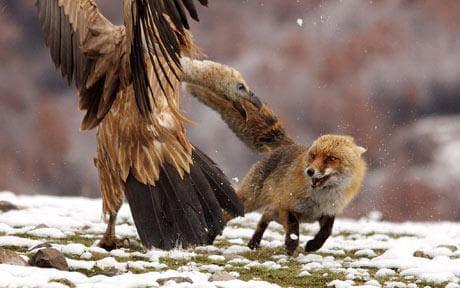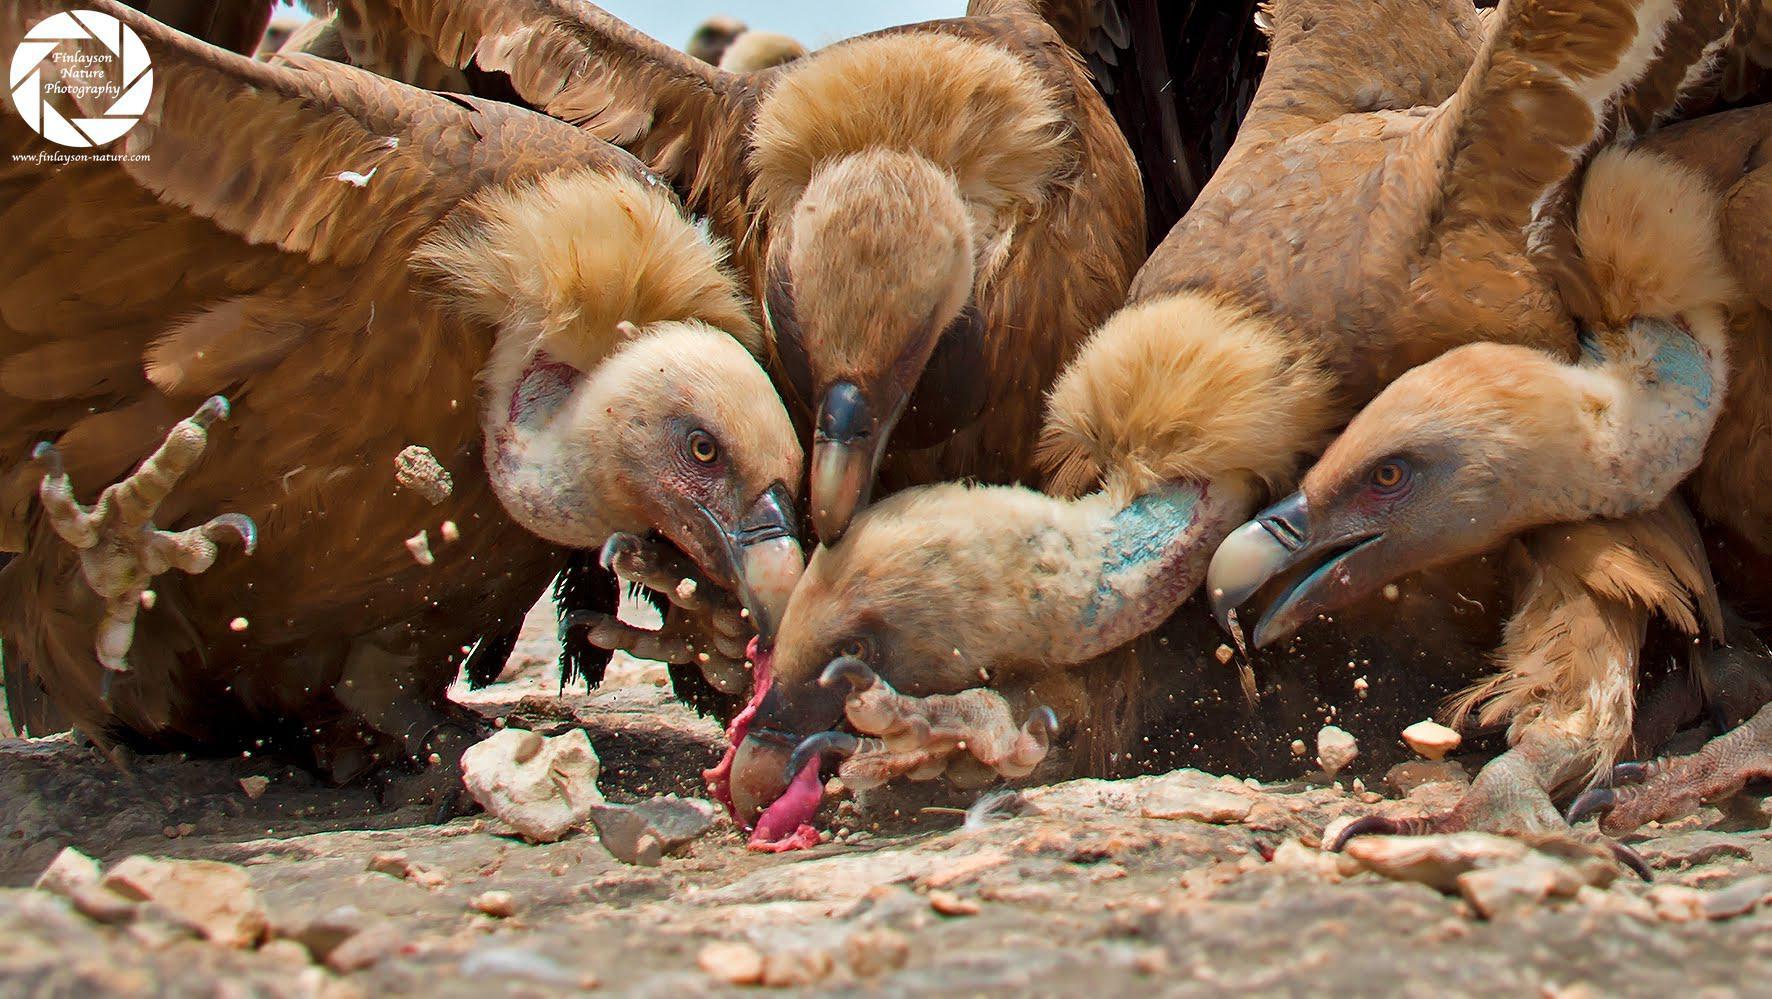The first image is the image on the left, the second image is the image on the right. Examine the images to the left and right. Is the description "There is a total of 1 fox with 1 or more buzzards." accurate? Answer yes or no. Yes. The first image is the image on the left, the second image is the image on the right. Analyze the images presented: Is the assertion "The left image has the exposed ribcage of an animal carcass." valid? Answer yes or no. No. 